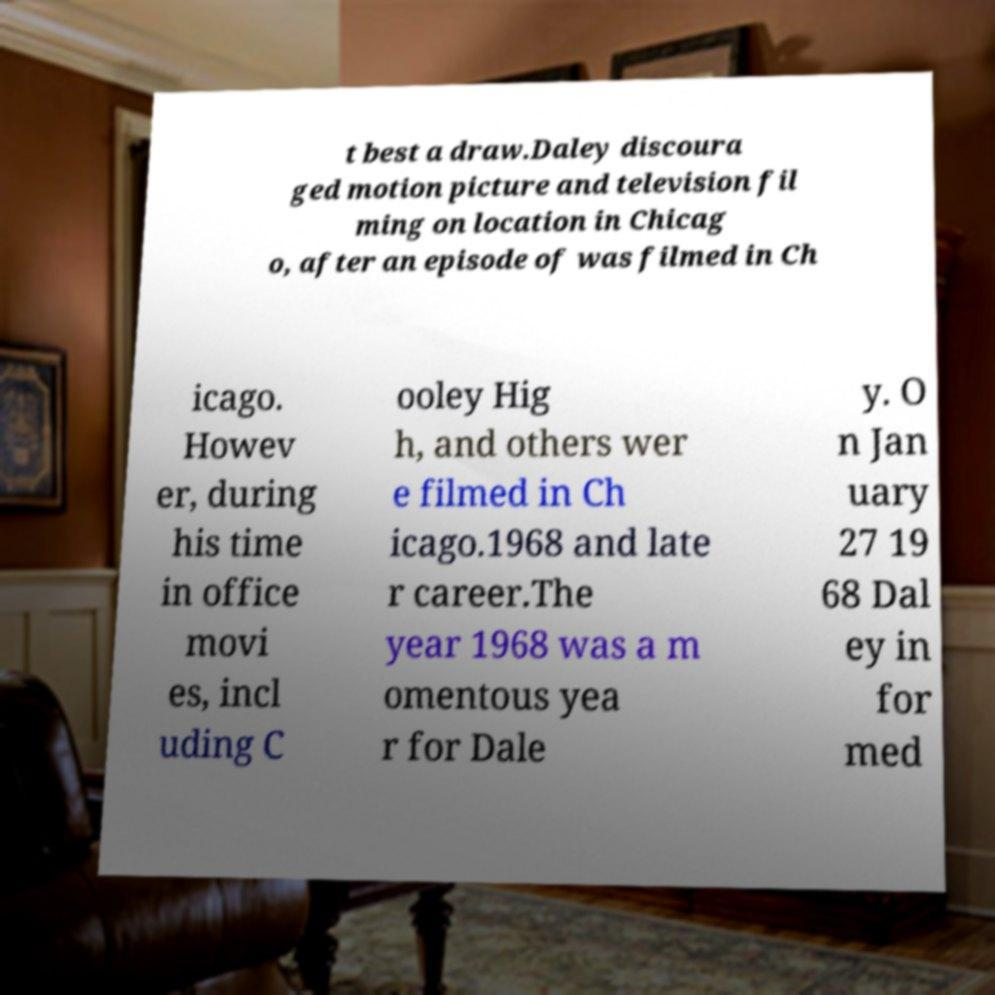What messages or text are displayed in this image? I need them in a readable, typed format. t best a draw.Daley discoura ged motion picture and television fil ming on location in Chicag o, after an episode of was filmed in Ch icago. Howev er, during his time in office movi es, incl uding C ooley Hig h, and others wer e filmed in Ch icago.1968 and late r career.The year 1968 was a m omentous yea r for Dale y. O n Jan uary 27 19 68 Dal ey in for med 